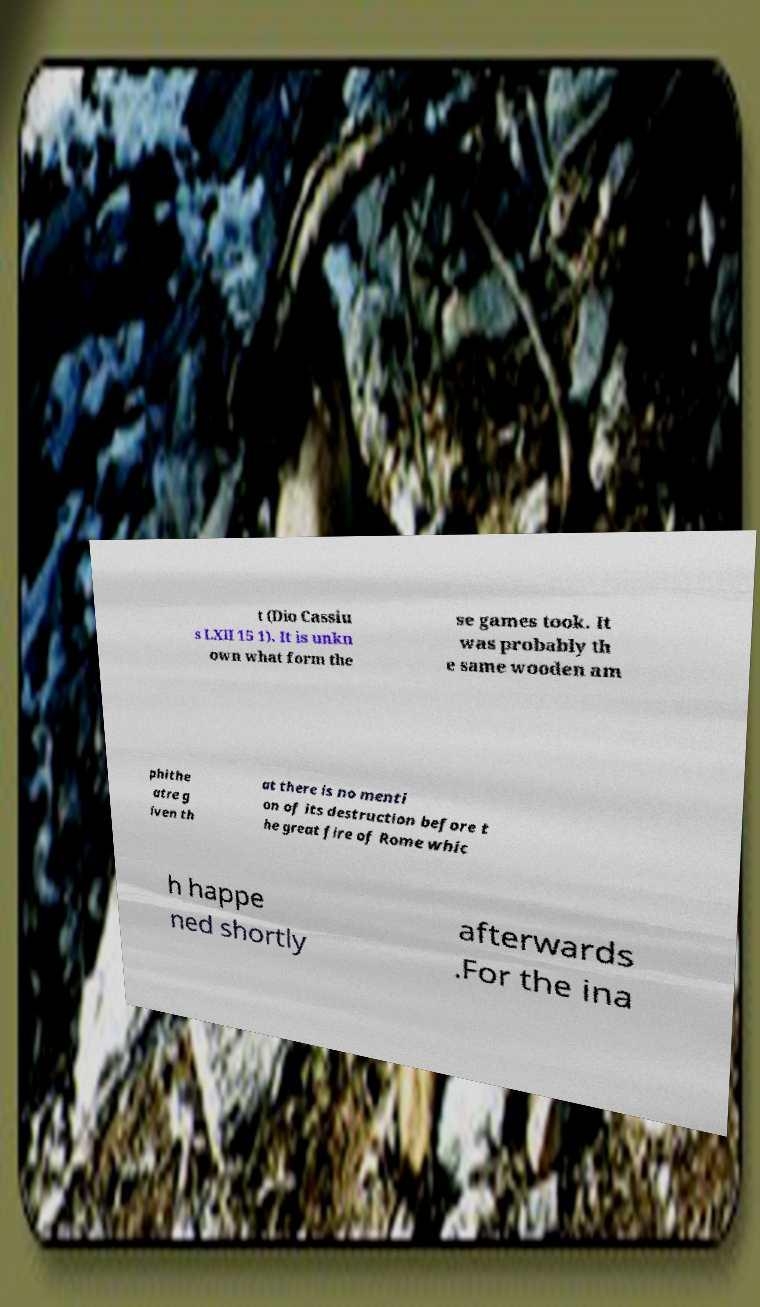What messages or text are displayed in this image? I need them in a readable, typed format. t (Dio Cassiu s LXII 15 1). It is unkn own what form the se games took. It was probably th e same wooden am phithe atre g iven th at there is no menti on of its destruction before t he great fire of Rome whic h happe ned shortly afterwards .For the ina 